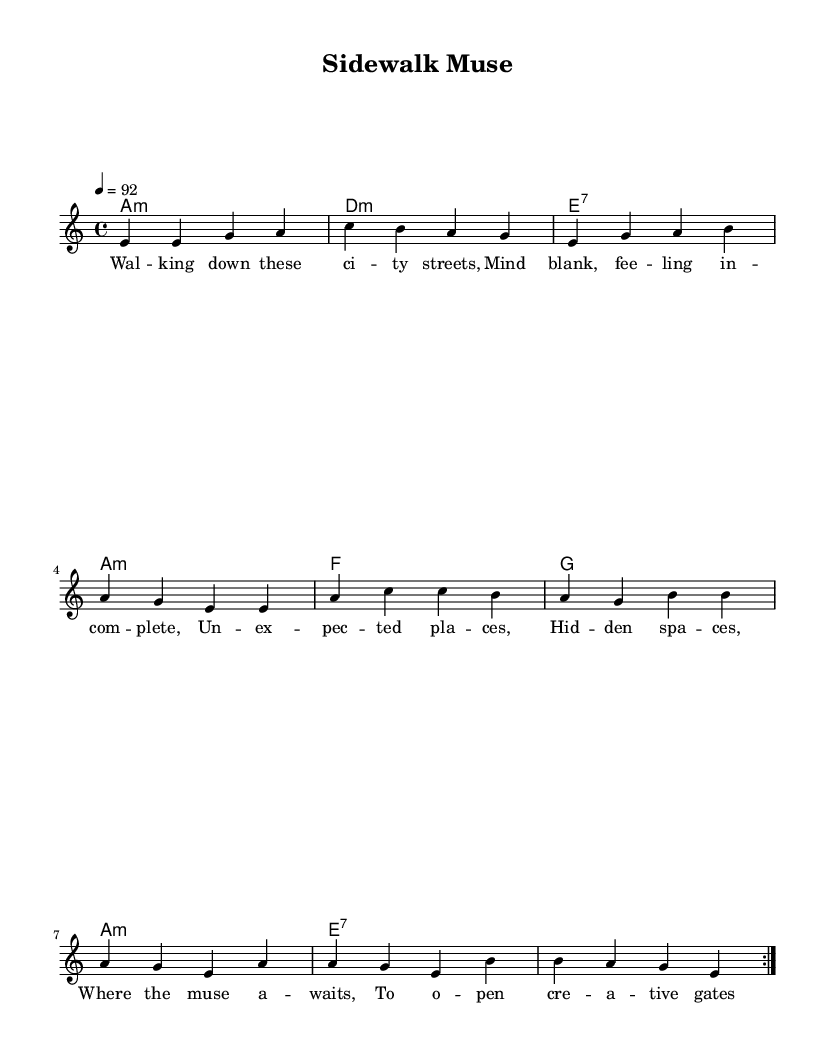What is the key signature of this music? The key signature is A minor, which contains no sharps or flats. This can be identified by looking at the key signature indicated at the beginning of the score.
Answer: A minor What is the time signature of the piece? The time signature is 4/4, which is indicated at the beginning of the score. This means there are four beats in each measure, and the quarter note gets one beat.
Answer: 4/4 What is the tempo marking of this piece? The tempo marking indicates that the piece should be played at a speed of 92 beats per minute. It is specified at the beginning of the score with the notation "4 = 92."
Answer: 92 How many measures are in the repeated section? The repeated section contains 8 measures. This can be determined by counting the measures in the repeated volta section.
Answer: 8 What type of chord is the first chord in the harmonies? The first chord is an A minor chord. This is identified in the chord mode where "a1:m" is noted, indicating it's an A minor chord.
Answer: A minor What lyrical theme is expressed in this piece? The lyrical theme expresses finding inspiration in unexpected places. This can be inferred from the lyrics, which describe walking through city streets and discovering hidden spaces.
Answer: Inspiration How does the structure of blues music reflect in this sheet? The structure of this piece follows a 12-bar blues format as seen in the harmonic progression. This is characteristic of blues music, which usually emphasizes a specific progression over 12 bars.
Answer: 12-bar 